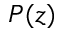<formula> <loc_0><loc_0><loc_500><loc_500>P ( z )</formula> 